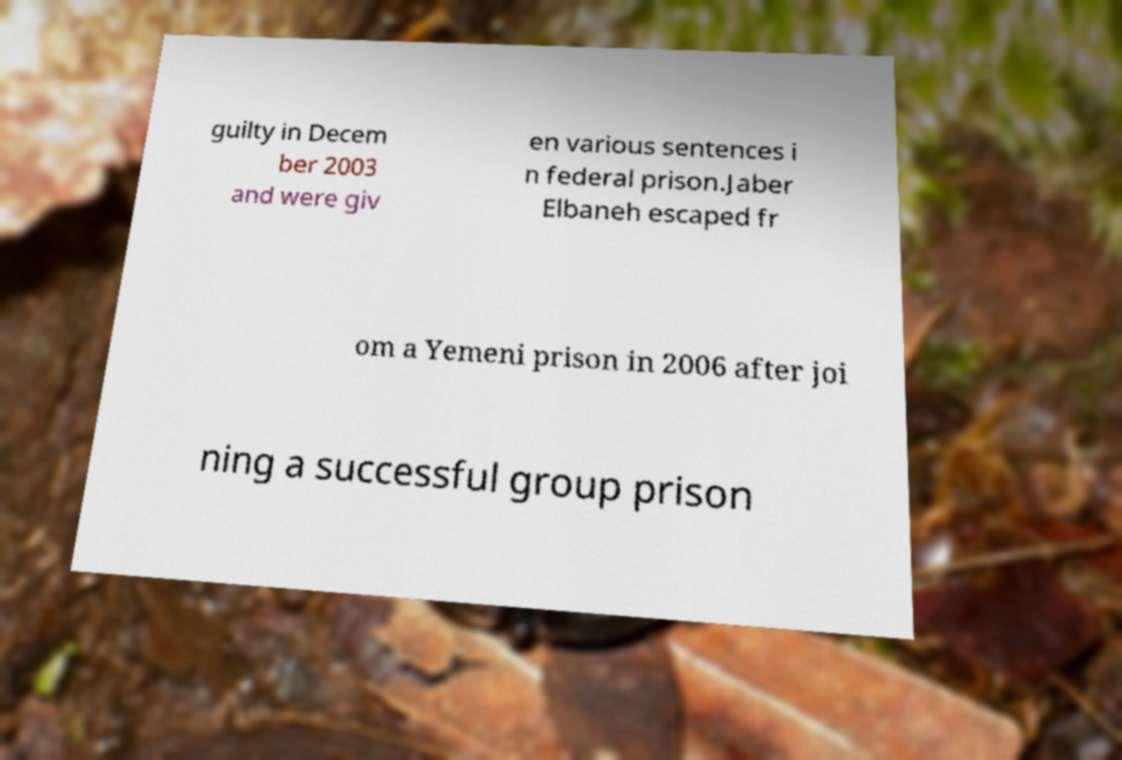For documentation purposes, I need the text within this image transcribed. Could you provide that? guilty in Decem ber 2003 and were giv en various sentences i n federal prison.Jaber Elbaneh escaped fr om a Yemeni prison in 2006 after joi ning a successful group prison 